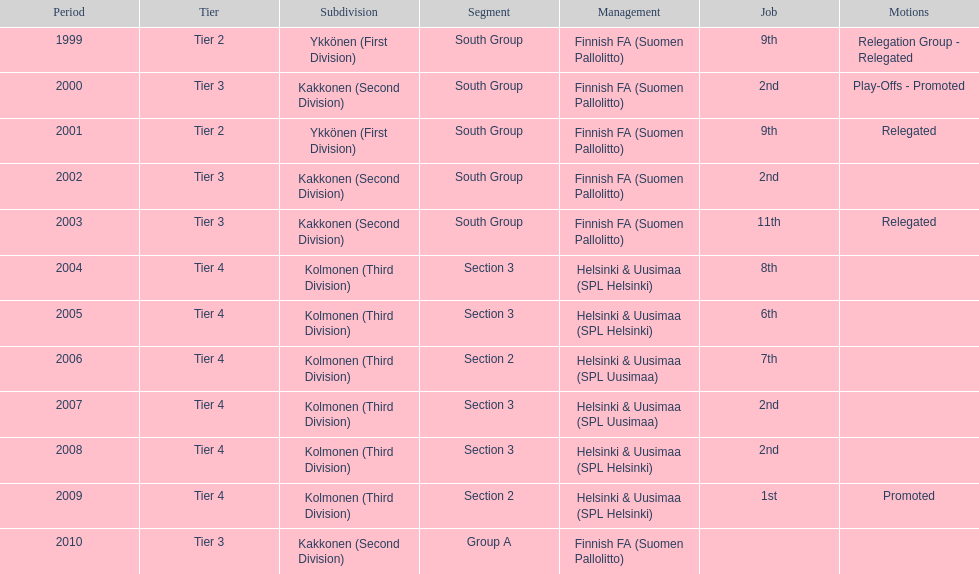How many consecutive times did they play in tier 4? 6. 